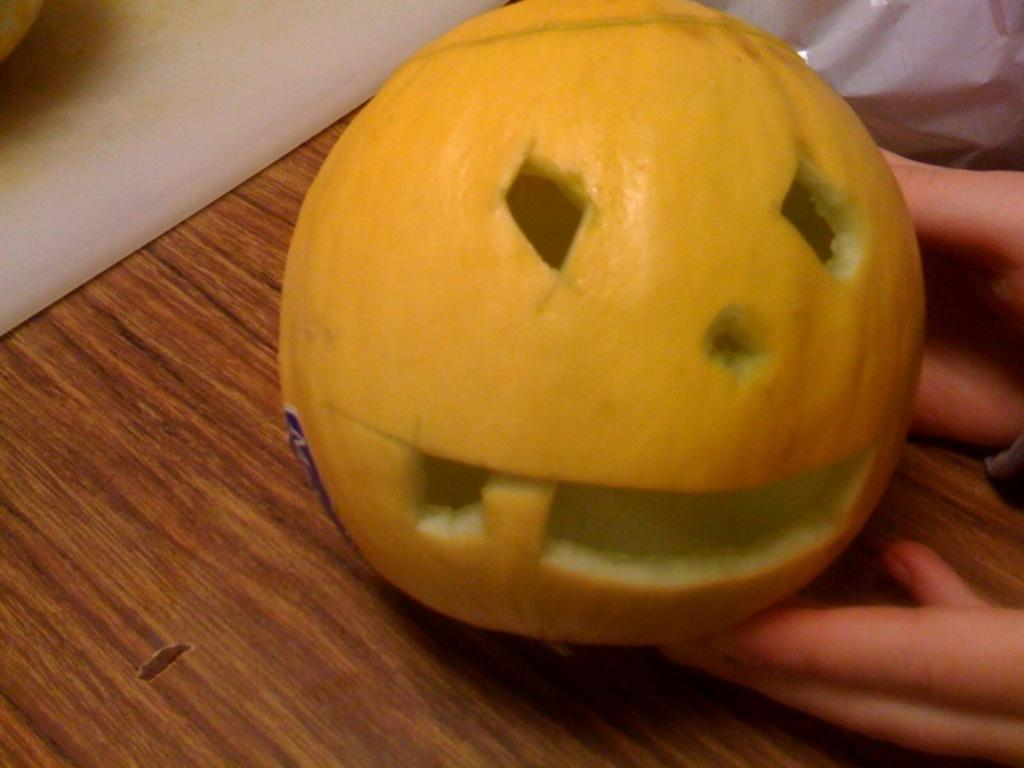What is the main subject of the image? There is a person in the image. What is the person holding in the image? The person is holding a pumpkin. Where is the pumpkin located in the image? The pumpkin is on a table. How many patches can be seen on the person's clothing in the image? There is no information about patches on the person's clothing in the image. 